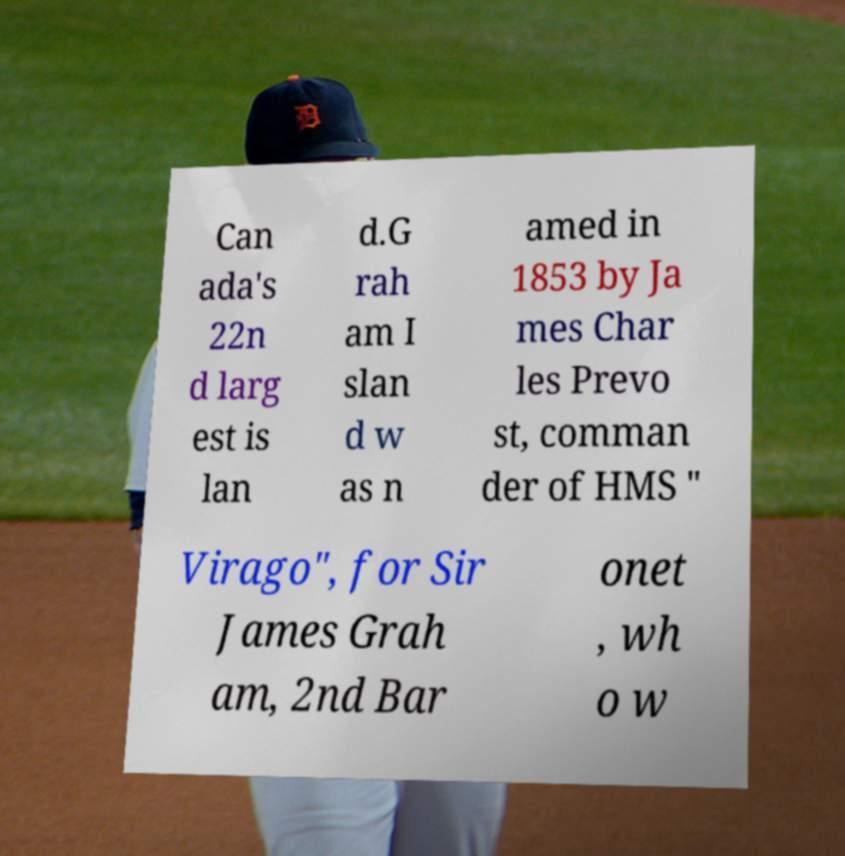Can you read and provide the text displayed in the image?This photo seems to have some interesting text. Can you extract and type it out for me? Can ada's 22n d larg est is lan d.G rah am I slan d w as n amed in 1853 by Ja mes Char les Prevo st, comman der of HMS " Virago", for Sir James Grah am, 2nd Bar onet , wh o w 